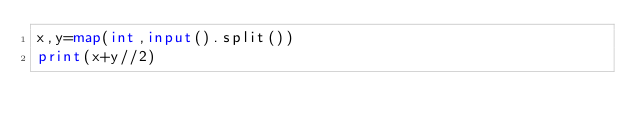<code> <loc_0><loc_0><loc_500><loc_500><_Python_>x,y=map(int,input().split())
print(x+y//2)</code> 